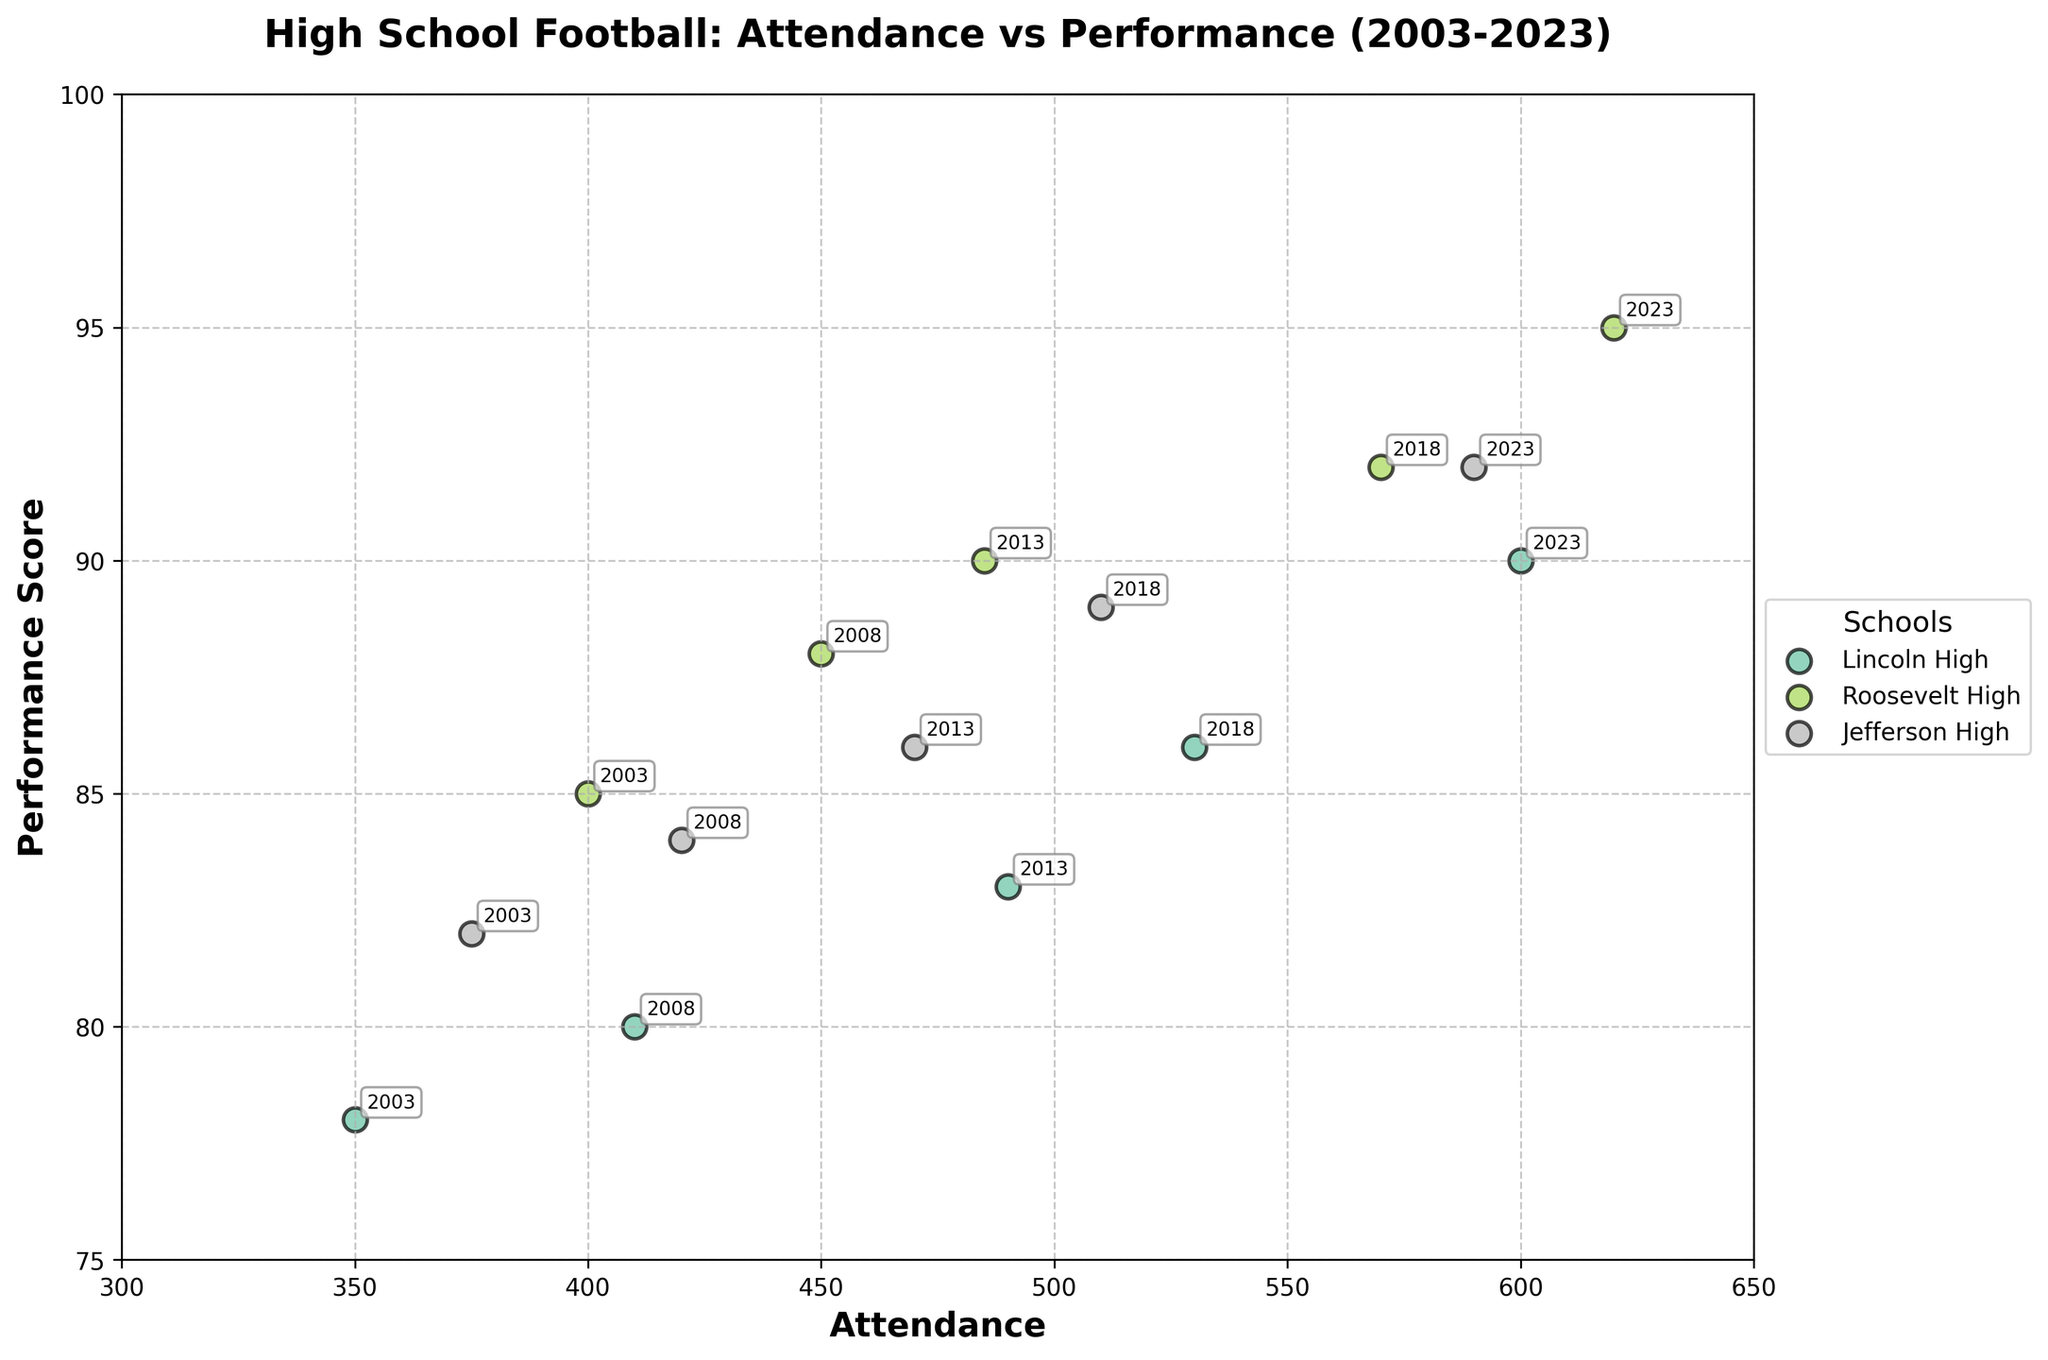What is the highest performance score recorded in the plot? Lincoln High, Roosevelt High, and Jefferson High all have scores plotted. The highest recorded score is 95, which comes from Roosevelt High in 2023.
Answer: 95 How many schools have data points for each year recorded in the plot? There are three schools (Lincoln High, Roosevelt High, Jefferson High) shown in the plot. Each school has a corresponding data point for each year (2003, 2008, 2013, 2018, 2023).
Answer: 3 Is there any school that continually increases its attendance over the years? Observing the plot, Roosevelt High's attendance increases at each data point from 2003 (400) to 2008 (450), 2013 (485), 2018 (570), and finally 2023 (620).
Answer: Yes, Roosevelt High Which school had the lowest attendance in 2003? Examining the plot, Lincoln High had an attendance of 350 in 2003, which is the lowest compared to Roosevelt High (400) and Jefferson High (375).
Answer: Lincoln High How has the performance score of Jefferson High changed from 2003 to 2023? Jefferson High's performance score was 82 in 2003 and increased to 84 in 2008, 86 in 2013, 89 in 2018, and reached 92 in 2023. This shows a consistent increase.
Answer: Increased Which year shows the greatest disparity in attendance between the schools? In 2018, Lincoln High had an attendance of 530, Roosevelt High had 570, and Jefferson High had 510. The difference between the highest (Roosevelt) and lowest (Jefferson) is 60.
Answer: 2018 What is the average performance score for Lincoln High across all recorded years? Lincoln High's performance scores across years are 78, 80, 83, 86, and 90. Summing these: 78 + 80 + 83 + 86 + 90 = 417. The average is 417/5 = 83.4
Answer: 83.4 In which year did all three schools have performance scores above 85? In 2023, Lincoln High had a score of 90, Roosevelt High had 95, and Jefferson High had 92, all above 85.
Answer: 2023 Which school has seen the most improvement in performance score from the beginning to the end of the period? Roosevelt High's performance score increased from 85 in 2003 to 95 in 2023, an improvement of 10 points. Lincoln High improved from 78 to 90 (12 points), and Jefferson High from 82 to 92 (10 points). Lincoln High shows the greatest improvement.
Answer: Lincoln High 